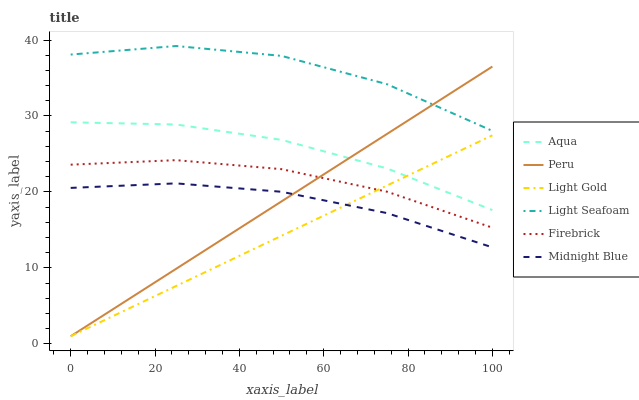Does Firebrick have the minimum area under the curve?
Answer yes or no. No. Does Firebrick have the maximum area under the curve?
Answer yes or no. No. Is Firebrick the smoothest?
Answer yes or no. No. Is Firebrick the roughest?
Answer yes or no. No. Does Firebrick have the lowest value?
Answer yes or no. No. Does Firebrick have the highest value?
Answer yes or no. No. Is Firebrick less than Light Seafoam?
Answer yes or no. Yes. Is Aqua greater than Firebrick?
Answer yes or no. Yes. Does Firebrick intersect Light Seafoam?
Answer yes or no. No. 